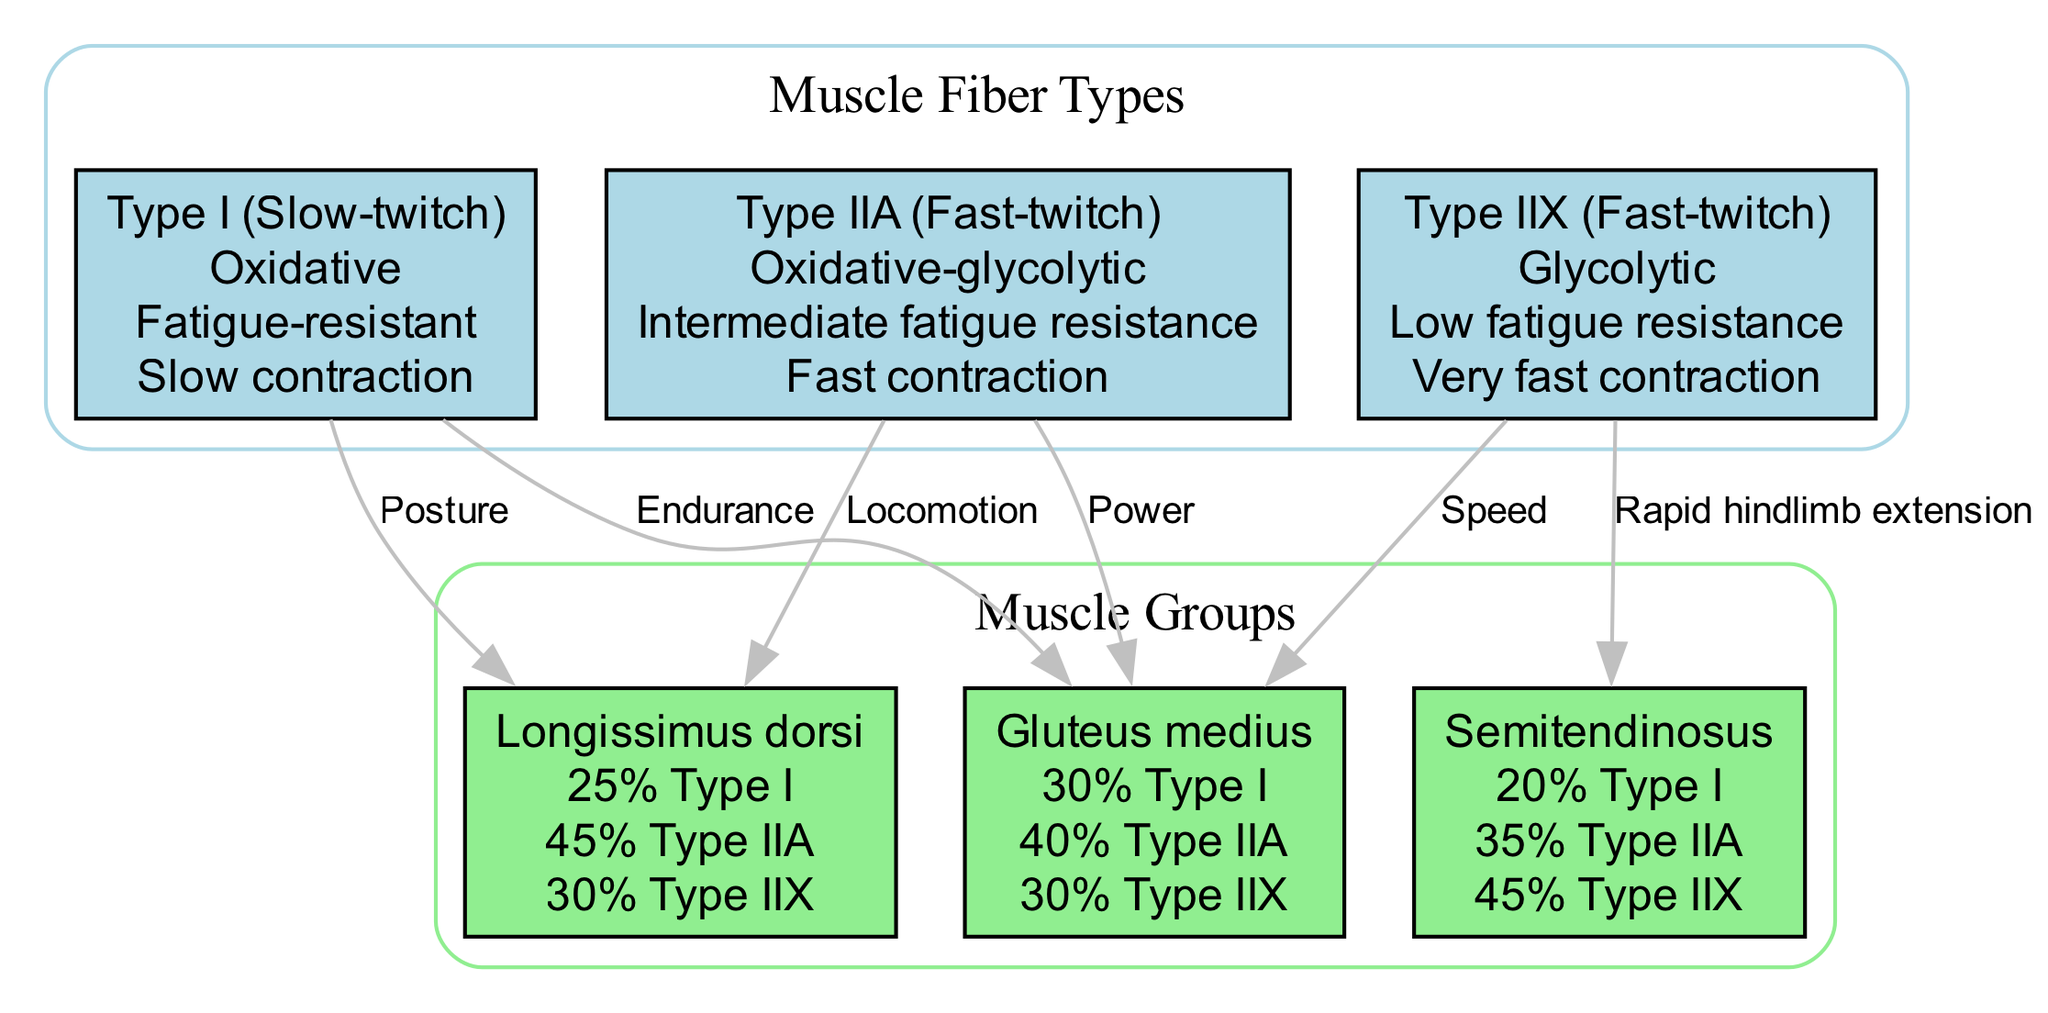What are the properties of Type I muscle fibers? The diagram states that Type I muscle fibers are oxidative, fatigue-resistant, and involved in slow contraction. These properties are listed directly under the Type I node in the diagram.
Answer: Oxidative, Fatigue-resistant, Slow contraction Which muscle group has the highest percentage of Type IIX fibers? According to the fiber composition of the muscle groups presented in the diagram, the Semitendinosus muscle has 45% Type IIX fibers, which is higher than the Gluteus medius and Longissimus dorsi.
Answer: Semitendinosus What is the primary role associated with Type I muscle fibers connected to the Gluteus medius? The diagram shows an edge connecting Type I to the Gluteus medius, labeled "Endurance." This indicates that Type I fibers are primarily associated with endurance in this muscle group.
Answer: Endurance How many different muscle fiber types are represented in the diagram? The diagram presents three different muscle fiber types: Type I, Type IIA, and Type IIX. This information is conveyed through the nodes in the "Muscle Fiber Types" section of the diagram.
Answer: Three What is the total percentage of Type IIA fibers in the Longissimus dorsi muscle? The diagram lists the fiber composition for Longissimus dorsi, which contains 45% Type IIA fibers. This is clearly stated in the muscle group's node.
Answer: 45% Which type of muscle fiber is primarily involved in rapid hindlimb extension? The Semitendinosus is connected to Type IIX fibers with an edge labeled "Rapid hindlimb extension." This indicates the role of Type IIX fibers in this action, as shown in the diagram.
Answer: Type IIX How many edges are shown in the diagram? By counting the connections (edges) between muscle fiber types and muscle groups in the diagram, there are six edges displayed in total that describe relationships and roles.
Answer: Six What type of muscle fiber is primarily associated with locomotion in the Longissimus dorsi? The diagram connects Type IIA fibers to the Longissimus dorsi with an edge labeled "Locomotion." This shows that Type IIA fibers are mainly involved in locomotion for this muscle group.
Answer: Type IIA 